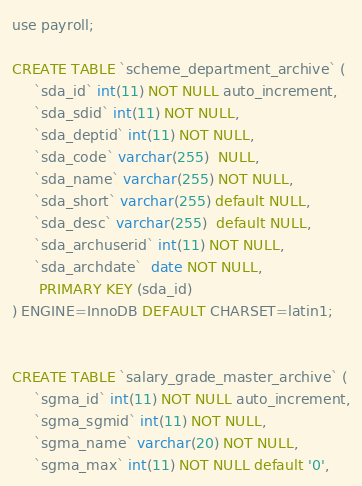<code> <loc_0><loc_0><loc_500><loc_500><_SQL_>use payroll;

CREATE TABLE `scheme_department_archive` (
     `sda_id` int(11) NOT NULL auto_increment,
     `sda_sdid` int(11) NOT NULL,
     `sda_deptid` int(11) NOT NULL,
     `sda_code` varchar(255)  NULL,
     `sda_name` varchar(255) NOT NULL,
     `sda_short` varchar(255) default NULL,
     `sda_desc` varchar(255)  default NULL,
     `sda_archuserid` int(11) NOT NULL,
     `sda_archdate`  date NOT NULL,
      PRIMARY KEY (sda_id)
) ENGINE=InnoDB DEFAULT CHARSET=latin1;


CREATE TABLE `salary_grade_master_archive` (
     `sgma_id` int(11) NOT NULL auto_increment,
     `sgma_sgmid` int(11) NOT NULL,
     `sgma_name` varchar(20) NOT NULL,
     `sgma_max` int(11) NOT NULL default '0',</code> 